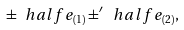Convert formula to latex. <formula><loc_0><loc_0><loc_500><loc_500>\pm \ h a l f e _ { ( 1 ) } \pm ^ { \prime } \ h a l f e _ { ( 2 ) } ,</formula> 